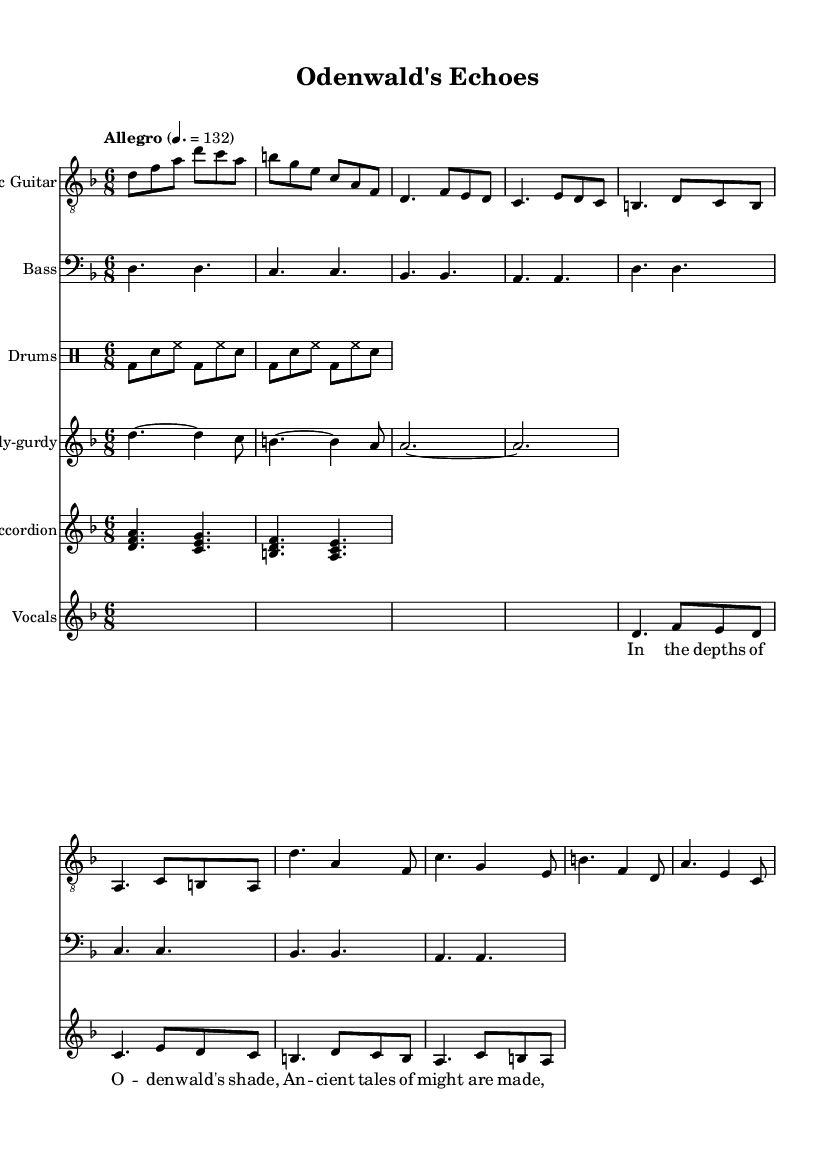What is the key signature of this music? The key signature is indicated by the symbols at the beginning of the staff. In this sheet music, there are no sharps or flats specified before the notes, implying a natural scale. This identifies the key signature as D minor.
Answer: D minor What is the time signature of this music? The time signature can be found at the beginning of the piece, right after the key signature. It shows how many beats are in each measure. Here, it is 6/8, which means there are six eighth notes per measure.
Answer: 6/8 What is the tempo marking of this music? The tempo marking is indicated by the text that appears at the start of the score. It reads "Allegro" with a specific number indicating the beats per minute (132). This provides the performing speed of the piece.
Answer: Allegro 4. = 132 Which instruments are included in this composition? Instruments are specified at the beginning of each staff in the score. By observing the staves, we see Electric Guitar, Bass, Drums, Hurdy-gurdy, Accordion, and Vocals.
Answer: Electric Guitar, Bass, Drums, Hurdy-gurdy, Accordion, Vocals What type of musical form is primarily used in the lyrics of this piece? Analyzing the lyrics presented, we notice a verse-chorus structure where the lyrics are presented in two sections: a verse and a chorus. This form is common in folk metal to tell stories.
Answer: Verse-Chorus How is the electric guitar part structured in terms of measures? By counting the measures of the electric guitar part explicitly shown in the score, we can observe that it spans a total of 8 measures before it corresponds with the vocals indicating a systematic arrangement.
Answer: 8 measures What narrative theme is suggested by the title and lyrics of the song? The title "Odenwald's Echoes" along with the lyrics hints at storytelling and ancient tales, characteristic of folk metal that often explores mythic themes. This narrative is supported by references to the location and the nature of the stories.
Answer: Ancient tales 